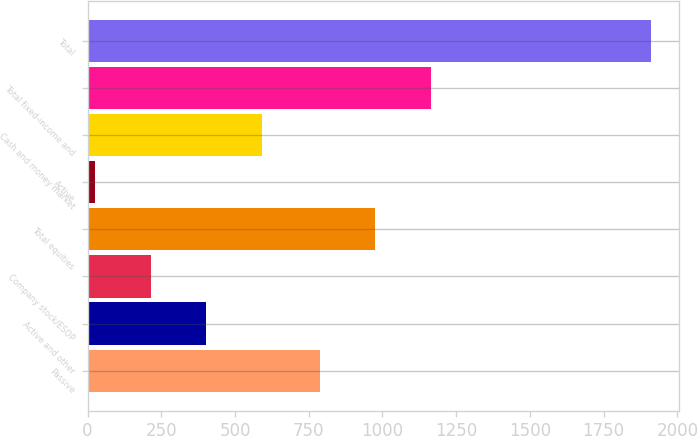Convert chart to OTSL. <chart><loc_0><loc_0><loc_500><loc_500><bar_chart><fcel>Passive<fcel>Active and other<fcel>Company stock/ESOP<fcel>Total equities<fcel>Active<fcel>Cash and money market<fcel>Total fixed-income and<fcel>Total<nl><fcel>787<fcel>402.2<fcel>213.6<fcel>975.6<fcel>25<fcel>590.8<fcel>1164.2<fcel>1911<nl></chart> 